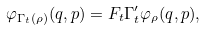<formula> <loc_0><loc_0><loc_500><loc_500>\varphi _ { \Gamma _ { t } ( \rho ) } ( q , p ) = F _ { t } \Gamma _ { t } ^ { \prime } \varphi _ { \rho } ( q , p ) ,</formula> 